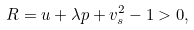Convert formula to latex. <formula><loc_0><loc_0><loc_500><loc_500>R = u + \lambda p + v _ { s } ^ { 2 } - 1 > 0 ,</formula> 